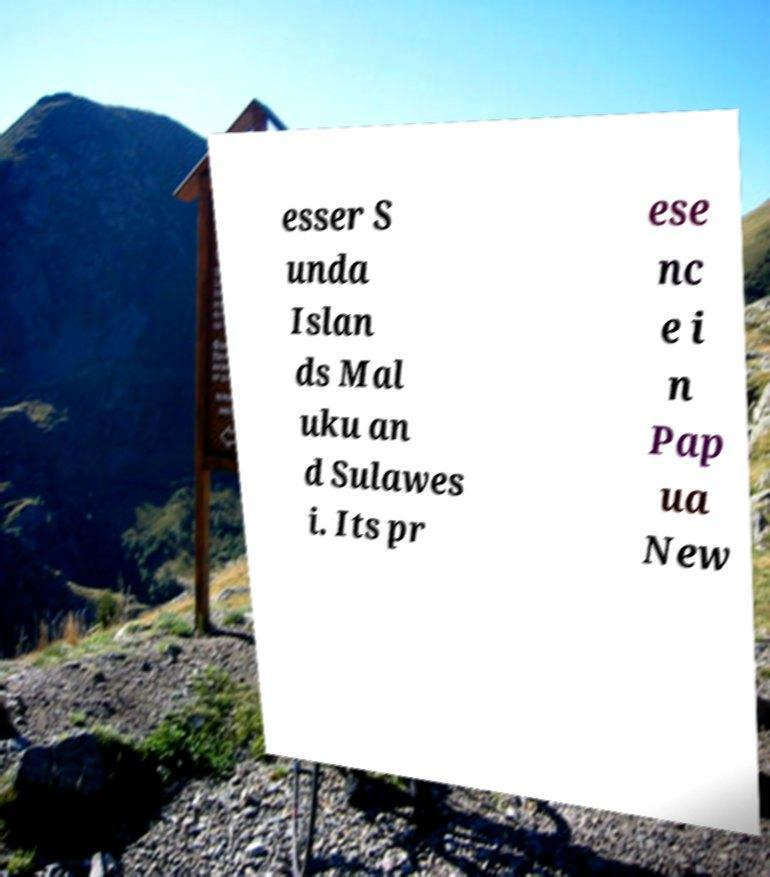Could you extract and type out the text from this image? esser S unda Islan ds Mal uku an d Sulawes i. Its pr ese nc e i n Pap ua New 